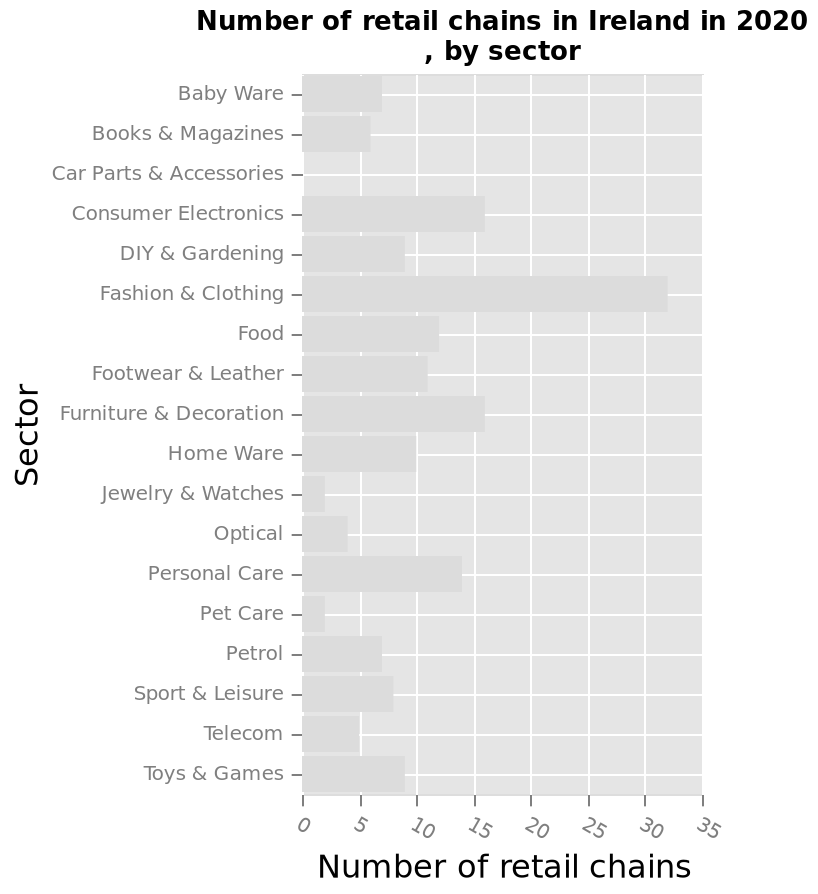<image>
Which industry is shown to have the lowest number of retail chains? Car Parts and accessories. What was the sector with the highest number of retail chains in Ireland in 2020?  To determine the sector with the highest number of retail chains in Ireland in 2020, you can refer to the bar chart and identify the sector with the highest bar on the y-axis. 